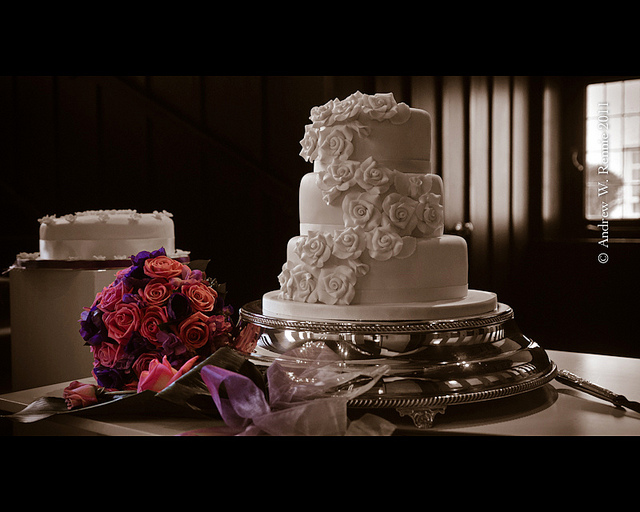Please extract the text content from this image. w 2011 